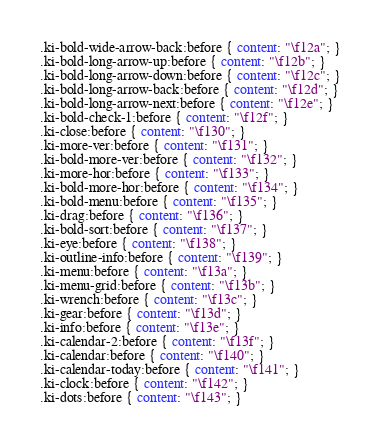<code> <loc_0><loc_0><loc_500><loc_500><_CSS_>.ki-bold-wide-arrow-back:before { content: "\f12a"; }
.ki-bold-long-arrow-up:before { content: "\f12b"; }
.ki-bold-long-arrow-down:before { content: "\f12c"; }
.ki-bold-long-arrow-back:before { content: "\f12d"; }
.ki-bold-long-arrow-next:before { content: "\f12e"; }
.ki-bold-check-1:before { content: "\f12f"; }
.ki-close:before { content: "\f130"; }
.ki-more-ver:before { content: "\f131"; }
.ki-bold-more-ver:before { content: "\f132"; }
.ki-more-hor:before { content: "\f133"; }
.ki-bold-more-hor:before { content: "\f134"; }
.ki-bold-menu:before { content: "\f135"; }
.ki-drag:before { content: "\f136"; }
.ki-bold-sort:before { content: "\f137"; }
.ki-eye:before { content: "\f138"; }
.ki-outline-info:before { content: "\f139"; }
.ki-menu:before { content: "\f13a"; }
.ki-menu-grid:before { content: "\f13b"; }
.ki-wrench:before { content: "\f13c"; }
.ki-gear:before { content: "\f13d"; }
.ki-info:before { content: "\f13e"; }
.ki-calendar-2:before { content: "\f13f"; }
.ki-calendar:before { content: "\f140"; }
.ki-calendar-today:before { content: "\f141"; }
.ki-clock:before { content: "\f142"; }
.ki-dots:before { content: "\f143"; }</code> 